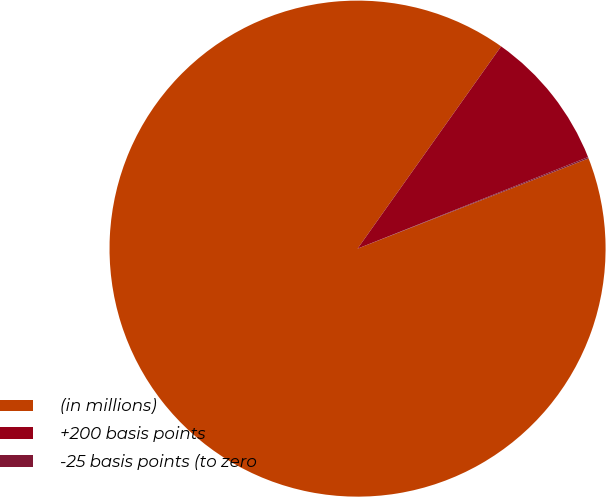Convert chart to OTSL. <chart><loc_0><loc_0><loc_500><loc_500><pie_chart><fcel>(in millions)<fcel>+200 basis points<fcel>-25 basis points (to zero<nl><fcel>90.75%<fcel>9.16%<fcel>0.09%<nl></chart> 